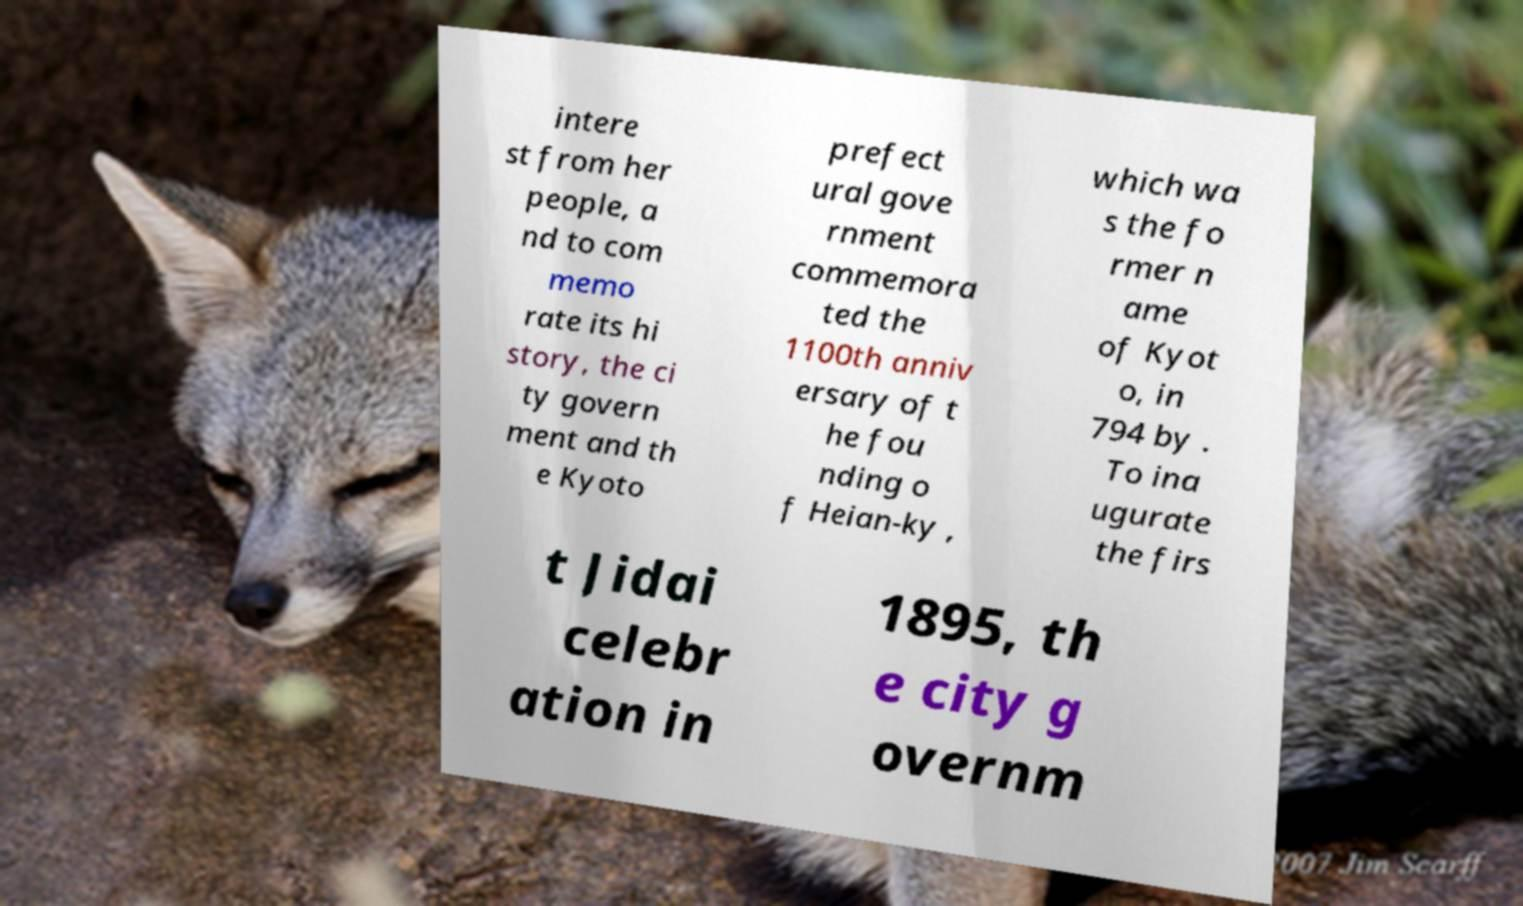I need the written content from this picture converted into text. Can you do that? intere st from her people, a nd to com memo rate its hi story, the ci ty govern ment and th e Kyoto prefect ural gove rnment commemora ted the 1100th anniv ersary of t he fou nding o f Heian-ky , which wa s the fo rmer n ame of Kyot o, in 794 by . To ina ugurate the firs t Jidai celebr ation in 1895, th e city g overnm 